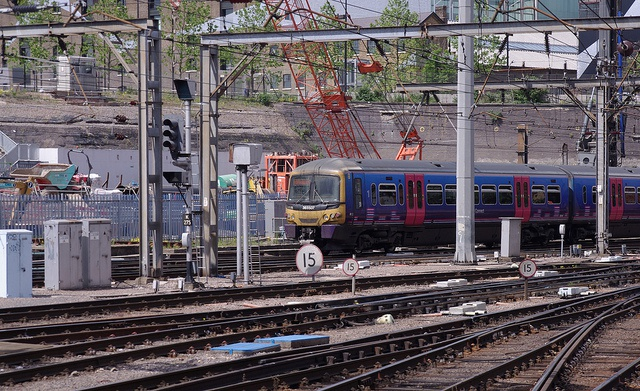Describe the objects in this image and their specific colors. I can see train in gray, black, navy, and darkgray tones and traffic light in gray and black tones in this image. 